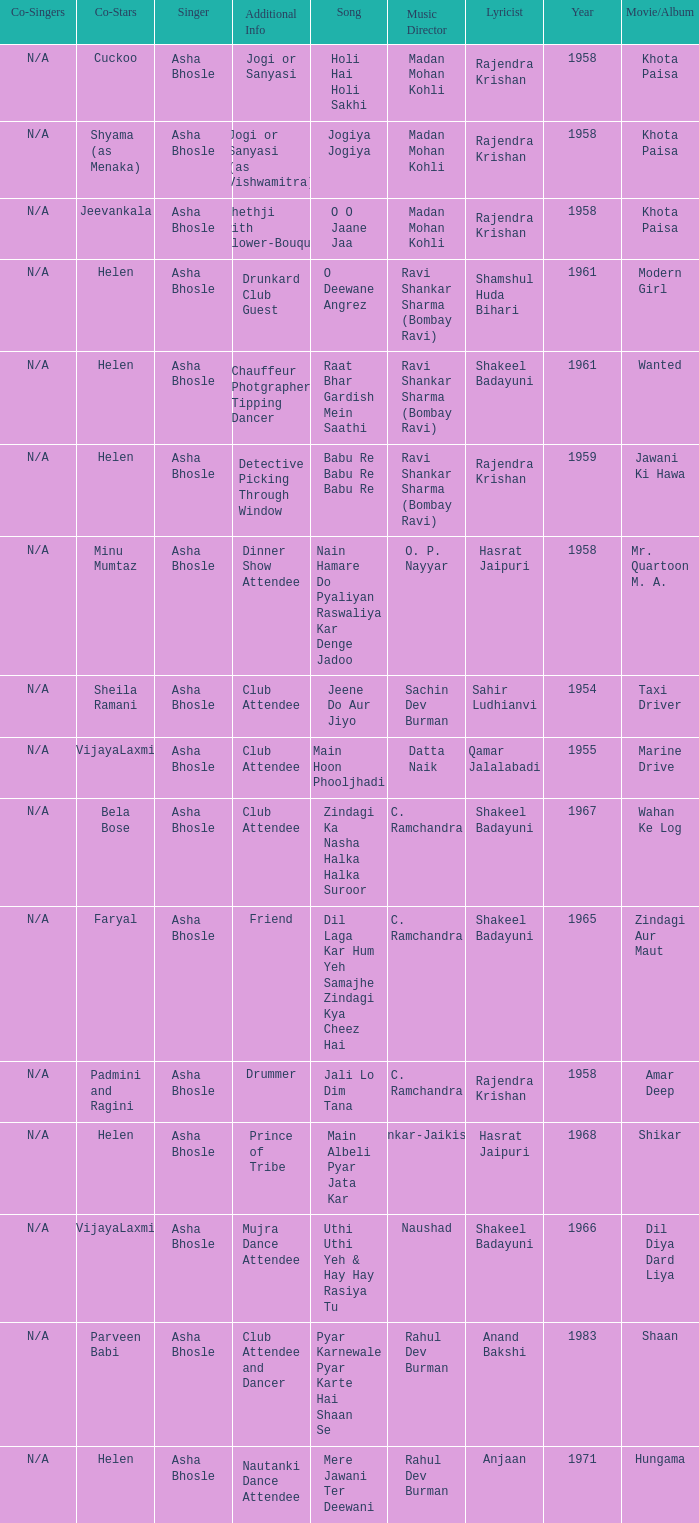What movie did Bela Bose co-star in? Wahan Ke Log. 